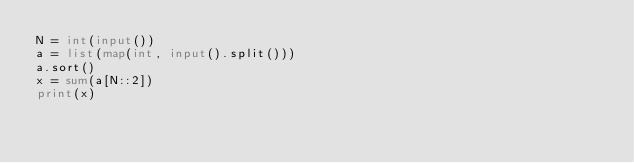Convert code to text. <code><loc_0><loc_0><loc_500><loc_500><_Python_>N = int(input())
a = list(map(int, input().split()))
a.sort()
x = sum(a[N::2])
print(x)
</code> 